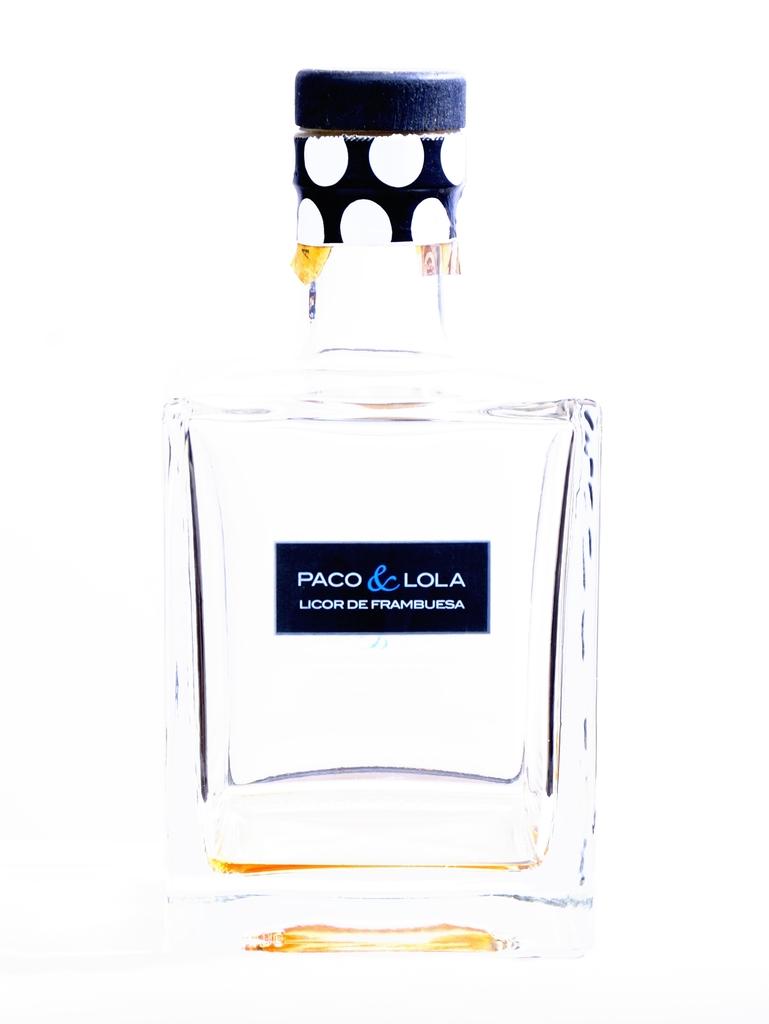Who made the perfume?
Your answer should be very brief. Paco & lola. 